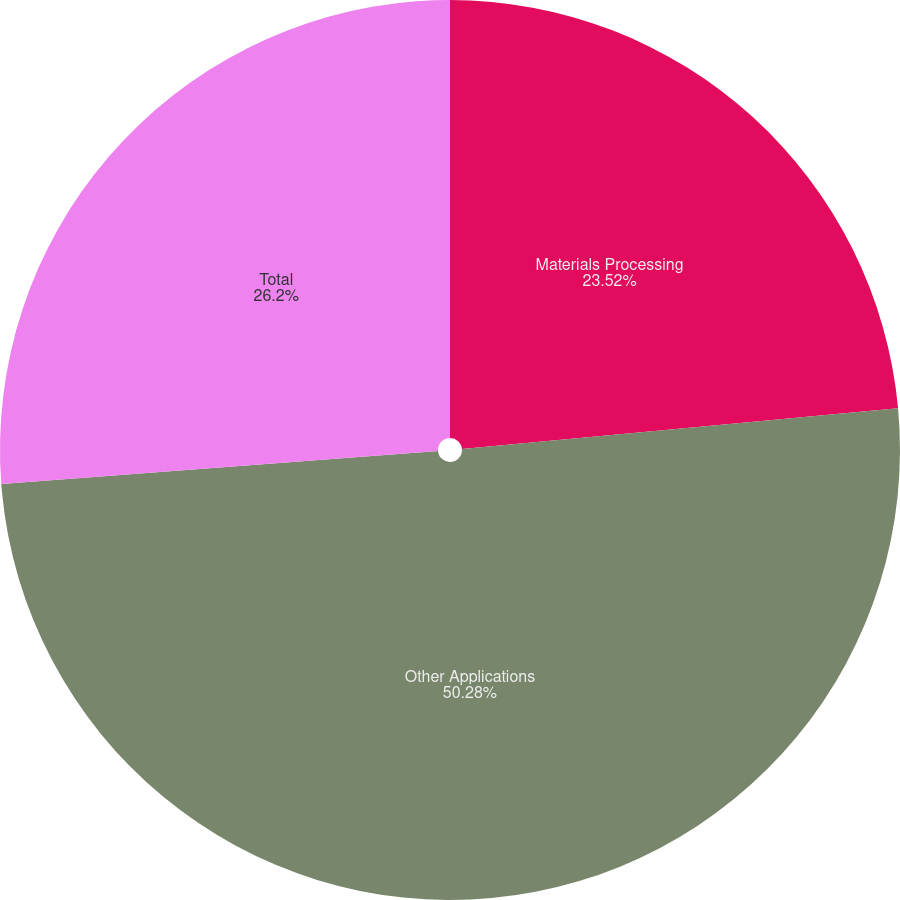Convert chart. <chart><loc_0><loc_0><loc_500><loc_500><pie_chart><fcel>Materials Processing<fcel>Other Applications<fcel>Total<nl><fcel>23.52%<fcel>50.28%<fcel>26.2%<nl></chart> 